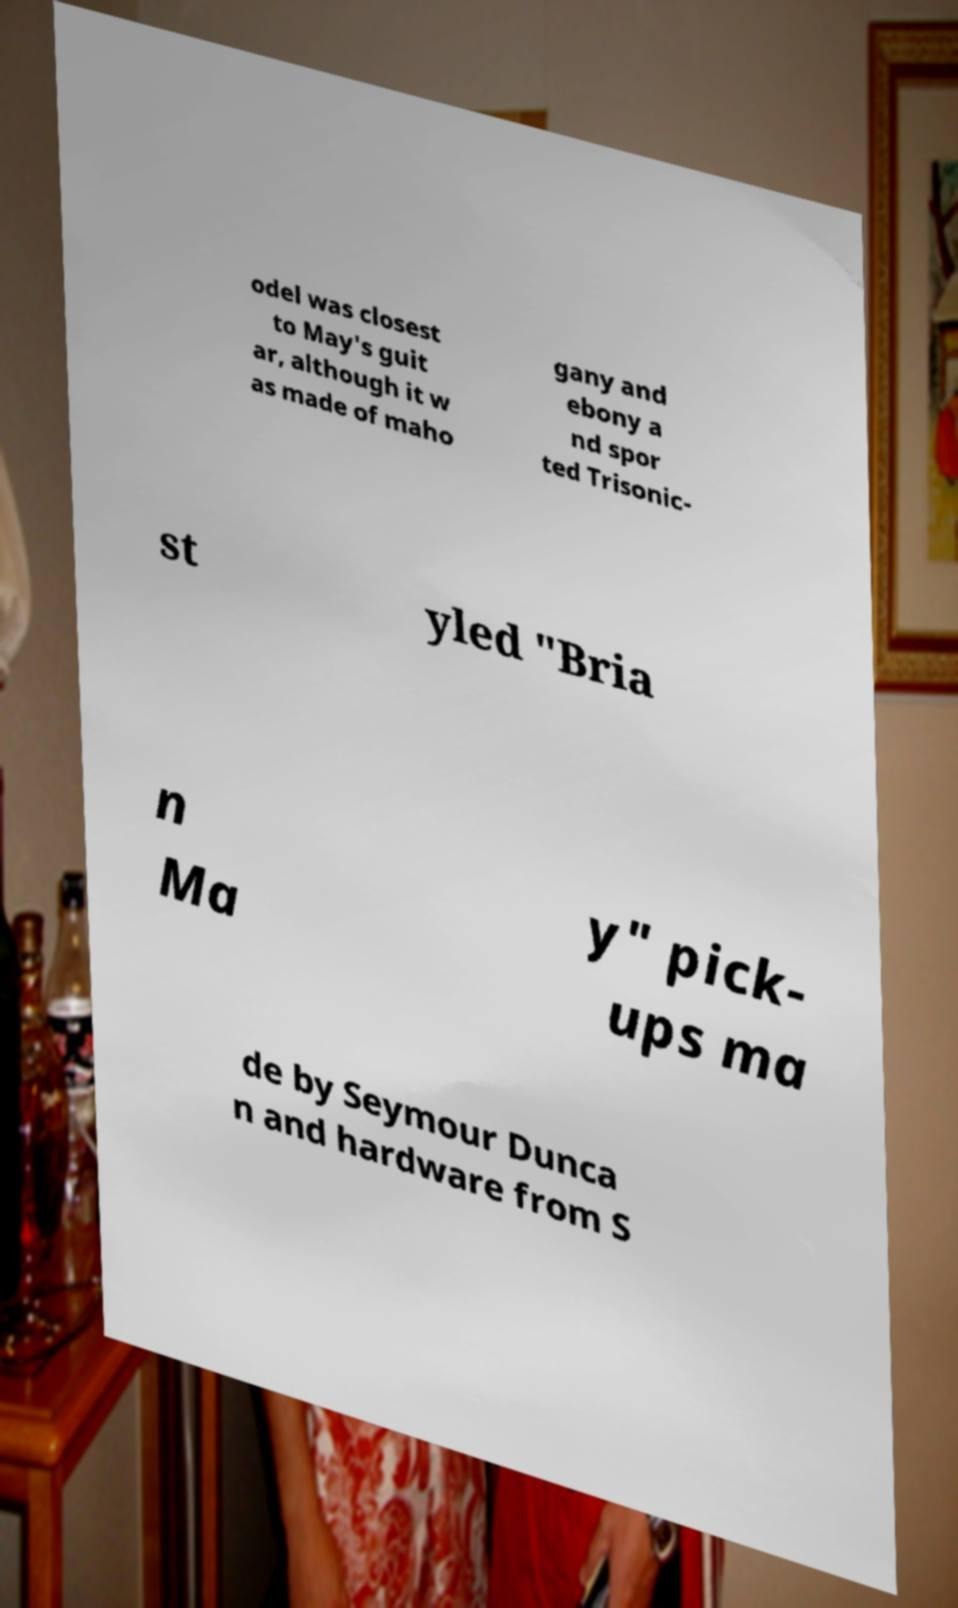I need the written content from this picture converted into text. Can you do that? odel was closest to May's guit ar, although it w as made of maho gany and ebony a nd spor ted Trisonic- st yled "Bria n Ma y" pick- ups ma de by Seymour Dunca n and hardware from S 